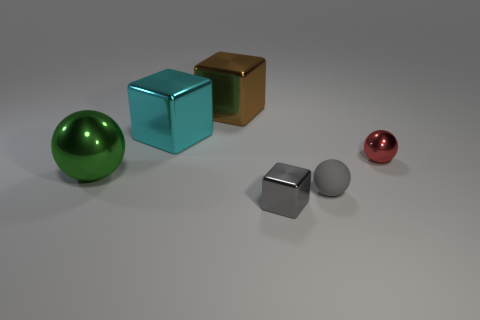Which object in the image appears to be the most reflective? The sphere to the left with a green hue appears to be the most reflective object, displaying clear specular highlights that indicate a smooth and shiny surface. 